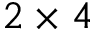Convert formula to latex. <formula><loc_0><loc_0><loc_500><loc_500>2 \times 4</formula> 